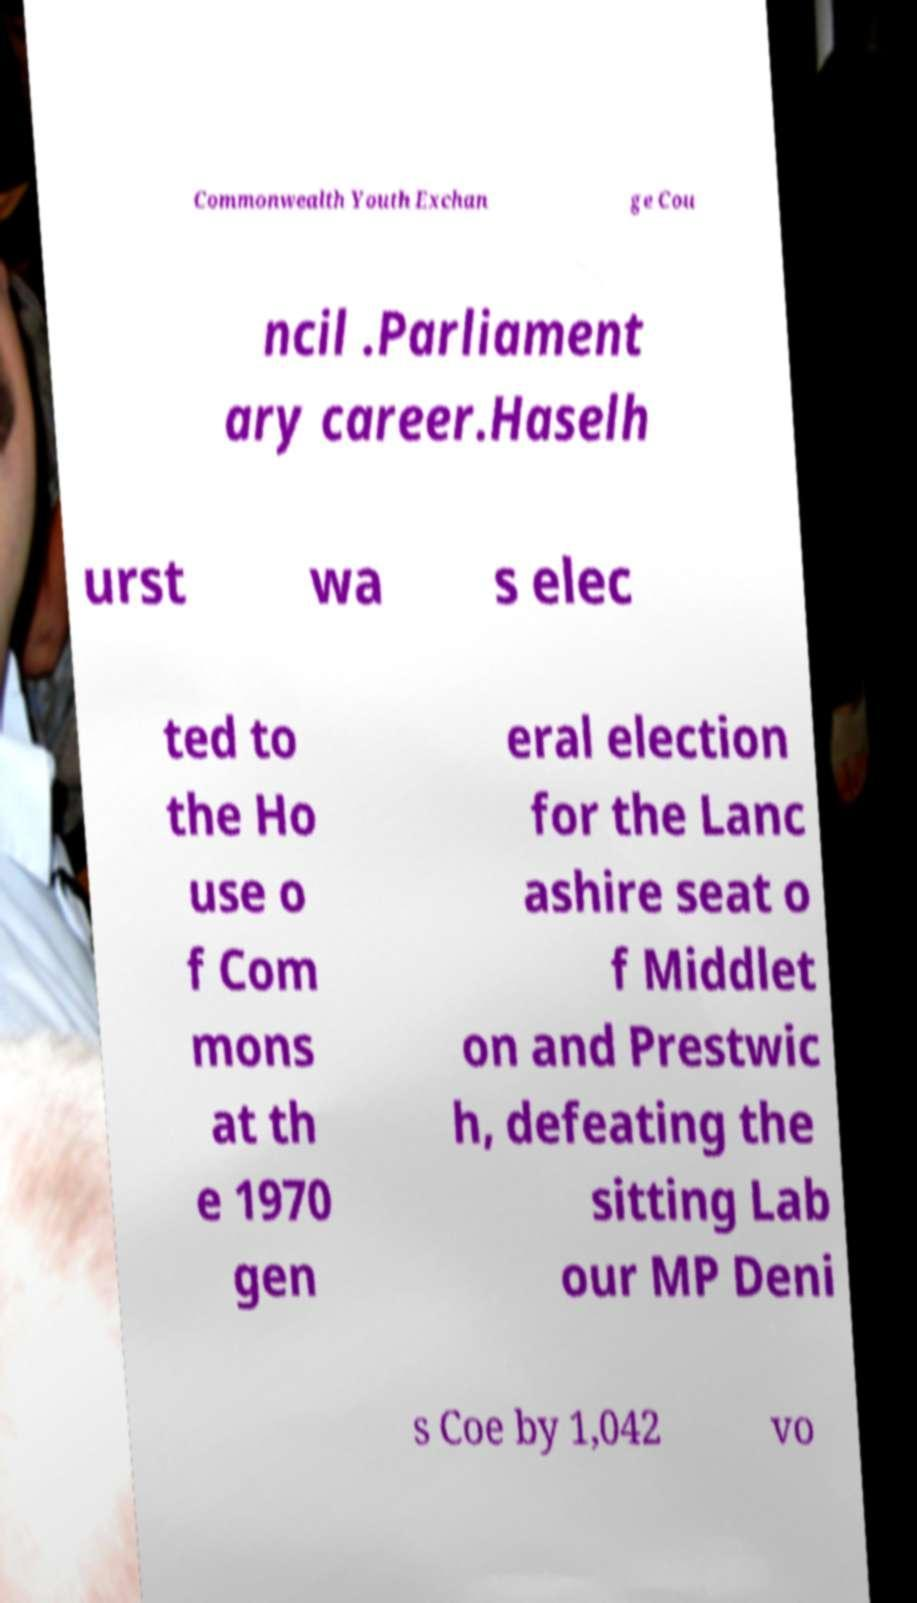There's text embedded in this image that I need extracted. Can you transcribe it verbatim? Commonwealth Youth Exchan ge Cou ncil .Parliament ary career.Haselh urst wa s elec ted to the Ho use o f Com mons at th e 1970 gen eral election for the Lanc ashire seat o f Middlet on and Prestwic h, defeating the sitting Lab our MP Deni s Coe by 1,042 vo 